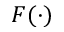Convert formula to latex. <formula><loc_0><loc_0><loc_500><loc_500>F ( \cdot )</formula> 